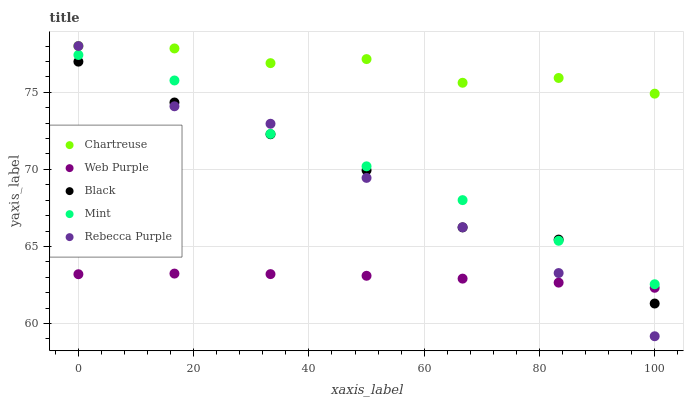Does Web Purple have the minimum area under the curve?
Answer yes or no. Yes. Does Chartreuse have the maximum area under the curve?
Answer yes or no. Yes. Does Black have the minimum area under the curve?
Answer yes or no. No. Does Black have the maximum area under the curve?
Answer yes or no. No. Is Web Purple the smoothest?
Answer yes or no. Yes. Is Black the roughest?
Answer yes or no. Yes. Is Chartreuse the smoothest?
Answer yes or no. No. Is Chartreuse the roughest?
Answer yes or no. No. Does Rebecca Purple have the lowest value?
Answer yes or no. Yes. Does Black have the lowest value?
Answer yes or no. No. Does Rebecca Purple have the highest value?
Answer yes or no. Yes. Does Black have the highest value?
Answer yes or no. No. Is Black less than Chartreuse?
Answer yes or no. Yes. Is Chartreuse greater than Web Purple?
Answer yes or no. Yes. Does Rebecca Purple intersect Black?
Answer yes or no. Yes. Is Rebecca Purple less than Black?
Answer yes or no. No. Is Rebecca Purple greater than Black?
Answer yes or no. No. Does Black intersect Chartreuse?
Answer yes or no. No. 